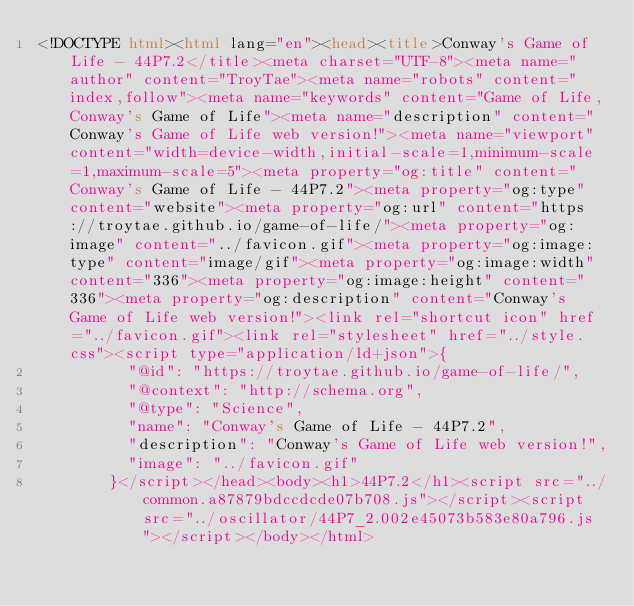Convert code to text. <code><loc_0><loc_0><loc_500><loc_500><_HTML_><!DOCTYPE html><html lang="en"><head><title>Conway's Game of Life - 44P7.2</title><meta charset="UTF-8"><meta name="author" content="TroyTae"><meta name="robots" content="index,follow"><meta name="keywords" content="Game of Life,Conway's Game of Life"><meta name="description" content="Conway's Game of Life web version!"><meta name="viewport" content="width=device-width,initial-scale=1,minimum-scale=1,maximum-scale=5"><meta property="og:title" content="Conway's Game of Life - 44P7.2"><meta property="og:type" content="website"><meta property="og:url" content="https://troytae.github.io/game-of-life/"><meta property="og:image" content="../favicon.gif"><meta property="og:image:type" content="image/gif"><meta property="og:image:width" content="336"><meta property="og:image:height" content="336"><meta property="og:description" content="Conway's Game of Life web version!"><link rel="shortcut icon" href="../favicon.gif"><link rel="stylesheet" href="../style.css"><script type="application/ld+json">{
          "@id": "https://troytae.github.io/game-of-life/",
          "@context": "http://schema.org",
          "@type": "Science",
          "name": "Conway's Game of Life - 44P7.2",
          "description": "Conway's Game of Life web version!",
          "image": "../favicon.gif"
        }</script></head><body><h1>44P7.2</h1><script src="../common.a87879bdccdcde07b708.js"></script><script src="../oscillator/44P7_2.002e45073b583e80a796.js"></script></body></html></code> 